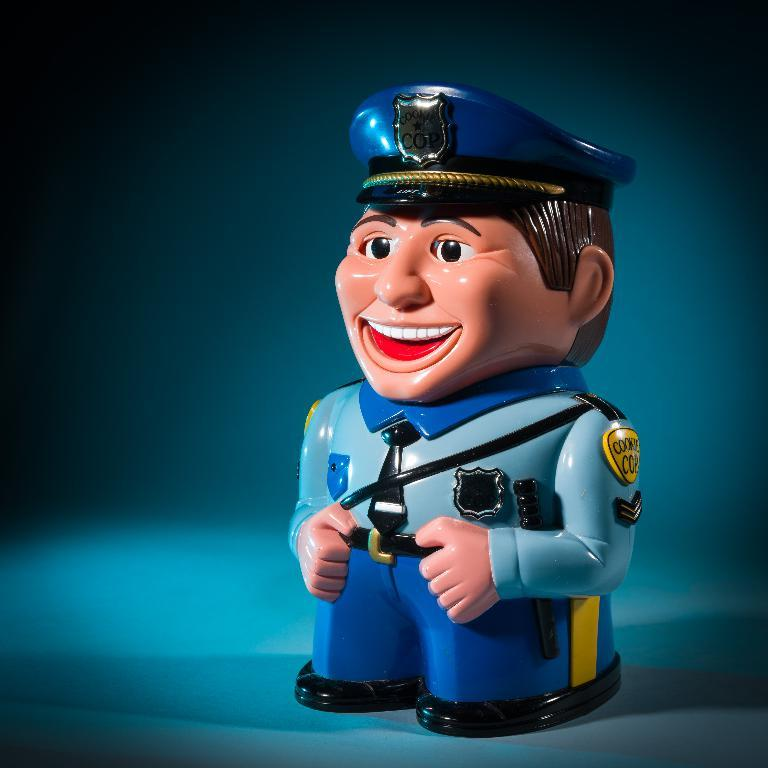What type of object is in the image? There is a toy of a man in the image. What is the man in the toy wearing? The man is wearing a uniform. What expression does the toy have? The toy has a smiling face. What color is the background of the image? The background of the image is blue. What subject is the toy teaching in the image? There is no indication in the image that the toy is teaching any subject. 